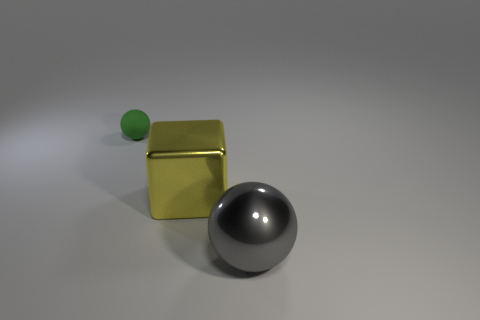Is the material of the ball that is right of the small green rubber thing the same as the large yellow block?
Give a very brief answer. Yes. Is there any other thing that is made of the same material as the large sphere?
Offer a terse response. Yes. What color is the other thing that is the same size as the yellow metallic thing?
Your answer should be very brief. Gray. Are there any tiny matte cubes of the same color as the metal cube?
Your response must be concise. No. There is a yellow object that is the same material as the big gray sphere; what size is it?
Provide a succinct answer. Large. How many other objects are the same size as the green rubber ball?
Keep it short and to the point. 0. What material is the large object in front of the yellow object?
Keep it short and to the point. Metal. There is a large metallic object that is on the left side of the ball that is in front of the ball that is on the left side of the big shiny block; what is its shape?
Ensure brevity in your answer.  Cube. Do the green thing and the yellow block have the same size?
Offer a terse response. No. How many things are small green objects or things that are behind the large gray object?
Make the answer very short. 2. 